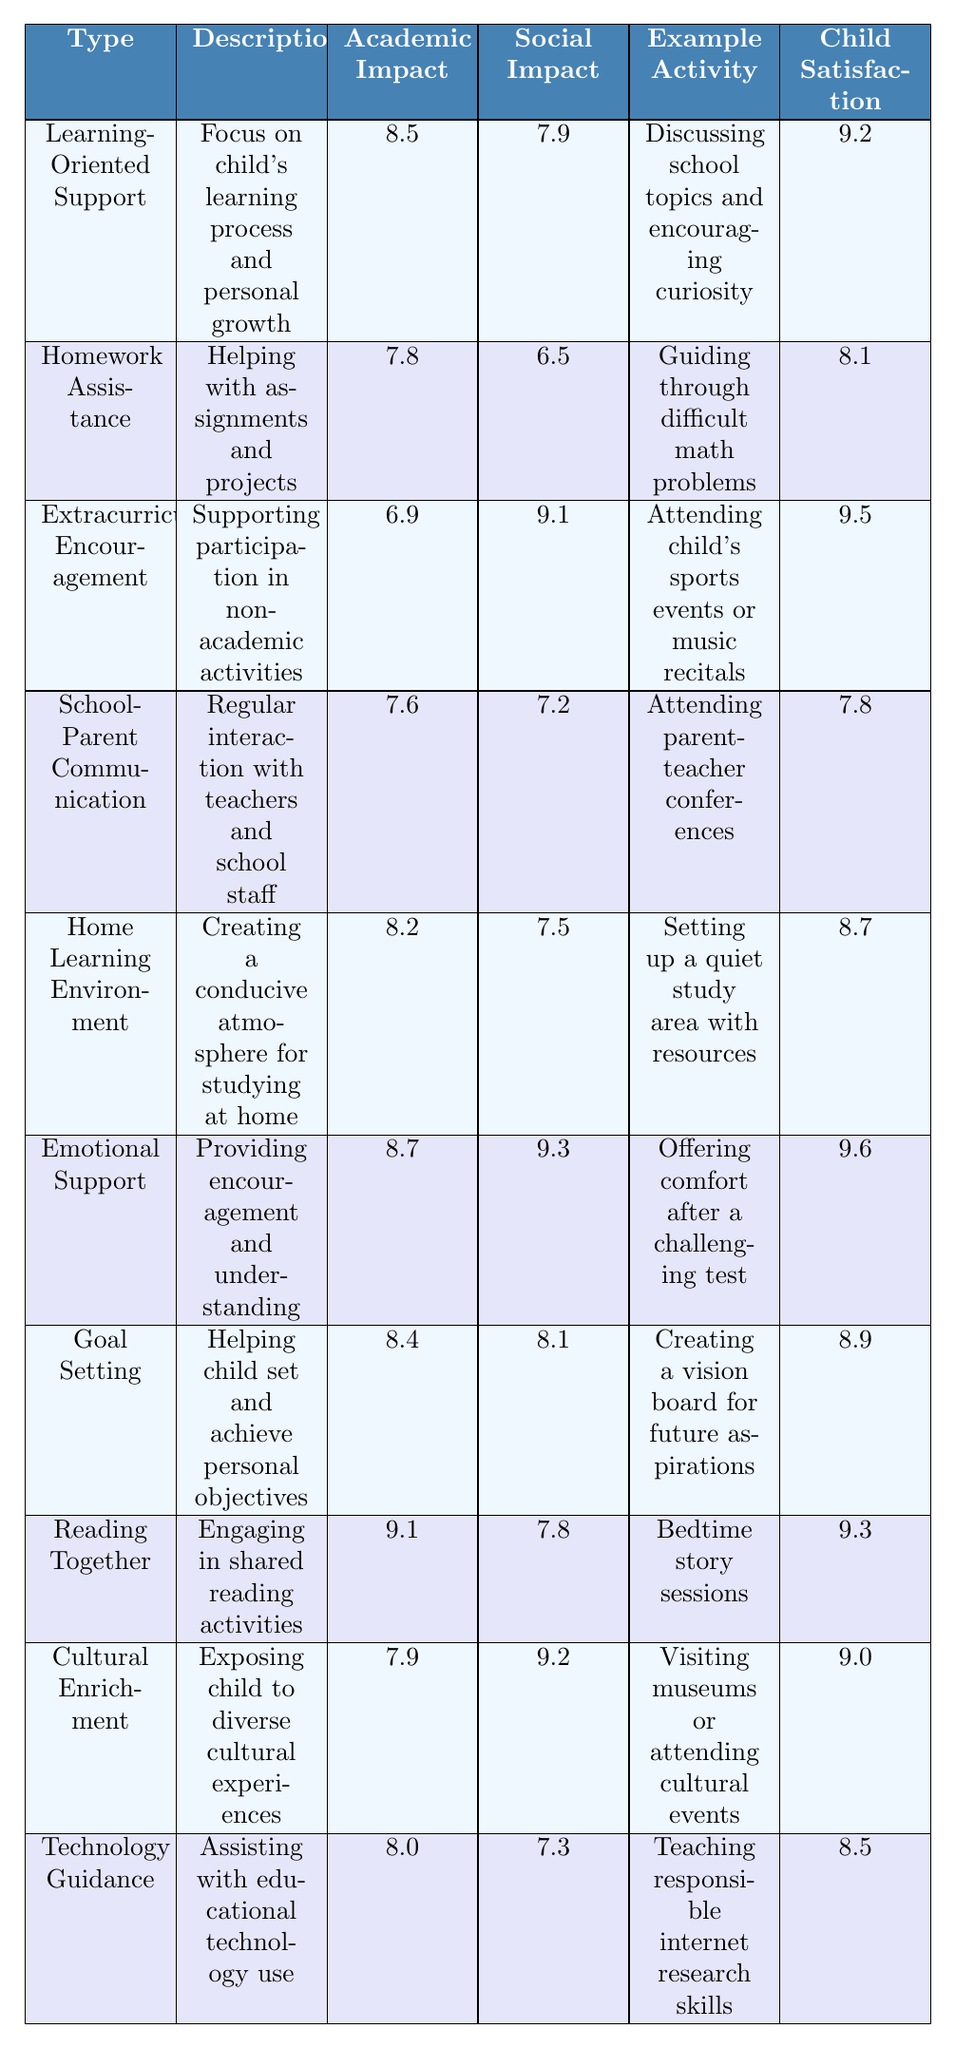What type of parental involvement has the highest academic impact? By examining the table, we find the "Reading Together" category has the highest academic impact score of 9.1, which is the highest among all listed types.
Answer: Reading Together Which type of parental involvement has the lowest social impact? Looking at the social impact scores, "Homework Assistance" has the lowest score with a value of 6.5.
Answer: Homework Assistance What is the average child satisfaction score for the different types of parental involvement? To find the average child satisfaction score, we sum all the scores (9.2 + 8.1 + 9.5 + 7.8 + 8.7 + 9.6 + 8.9 + 9.3 + 9.0 + 8.5 = 88.6) and divide by the total number of types (10), resulting in 88.6 / 10 = 8.86.
Answer: 8.86 Is the emotional support type among the top three for both academic and social impact? The emotional support has an academic impact of 8.7 and a social impact of 9.3. By comparing these scores, only "Reading Together" and "Learning-Oriented Support" have scores greater than or equal to 8.7 academically; thus, emotional support ranks in the top three for social impact.
Answer: Yes What impact type has a combination of the highest academic impact and the highest child satisfaction? "Reading Together" has the highest academic impact at 9.1 and a child satisfaction score of 9.3, which is also among the highest satisfaction scores. No other type has both an academic impact score and child satisfaction higher than this.
Answer: Reading Together How does the impact of "Extracurricular Encouragement" compare to "Technology Guidance" in terms of social impact? "Extracurricular Encouragement" has a social impact score of 9.1, while "Technology Guidance" has a score of 7.3. The difference is 9.1 - 7.3 = 1.8, indicating that extracurricular encouragement significantly influences social outcomes more than technology guidance.
Answer: 1.8 Which type of involvement has a greater academic impact than social impact? "Homework Assistance" and "School-Parent Communication" are both examples, showing an academic impact score greater than that of their social impact (7.8 > 6.5 and 7.6 > 7.2 respectively).
Answer: Homework Assistance and School-Parent Communication What is the difference in child satisfaction between "Emotional Support" and "Homework Assistance"? The child satisfaction score for "Emotional Support" is 9.6, and for "Homework Assistance," it is 8.1. The difference is calculated as 9.6 - 8.1 = 1.5. This indicates that emotional support is rated higher in terms of satisfaction.
Answer: 1.5 Which type of involvement is the best overall for child satisfaction? "Emotional Support" has the highest child satisfaction value of 9.6, making it the best overall in this category among the types listed.
Answer: Emotional Support Does "Cultural Enrichment" have a higher academic impact than "Goal Setting"? "Cultural Enrichment" has an academic impact score of 7.9, while "Goal Setting" has 8.4. When we compare the two, we see that 7.9 is less than 8.4.
Answer: No 